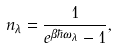Convert formula to latex. <formula><loc_0><loc_0><loc_500><loc_500>n _ { \lambda } = \frac { 1 } { e ^ { \beta \hbar { \omega } _ { \lambda } } - 1 } ,</formula> 